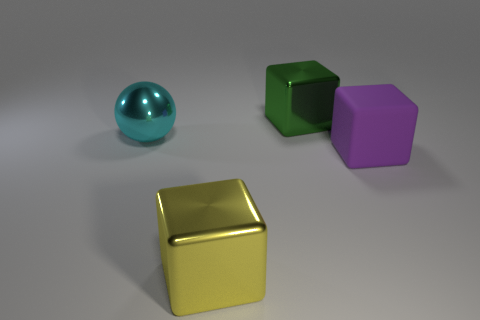Subtract all big metallic blocks. How many blocks are left? 1 Add 2 cubes. How many objects exist? 6 Subtract all yellow cubes. How many cubes are left? 2 Subtract 1 spheres. How many spheres are left? 0 Subtract all cyan cylinders. How many green cubes are left? 1 Subtract all blue rubber balls. Subtract all large yellow metal blocks. How many objects are left? 3 Add 4 large cyan metallic things. How many large cyan metallic things are left? 5 Add 4 cyan cubes. How many cyan cubes exist? 4 Subtract 0 brown blocks. How many objects are left? 4 Subtract all blocks. How many objects are left? 1 